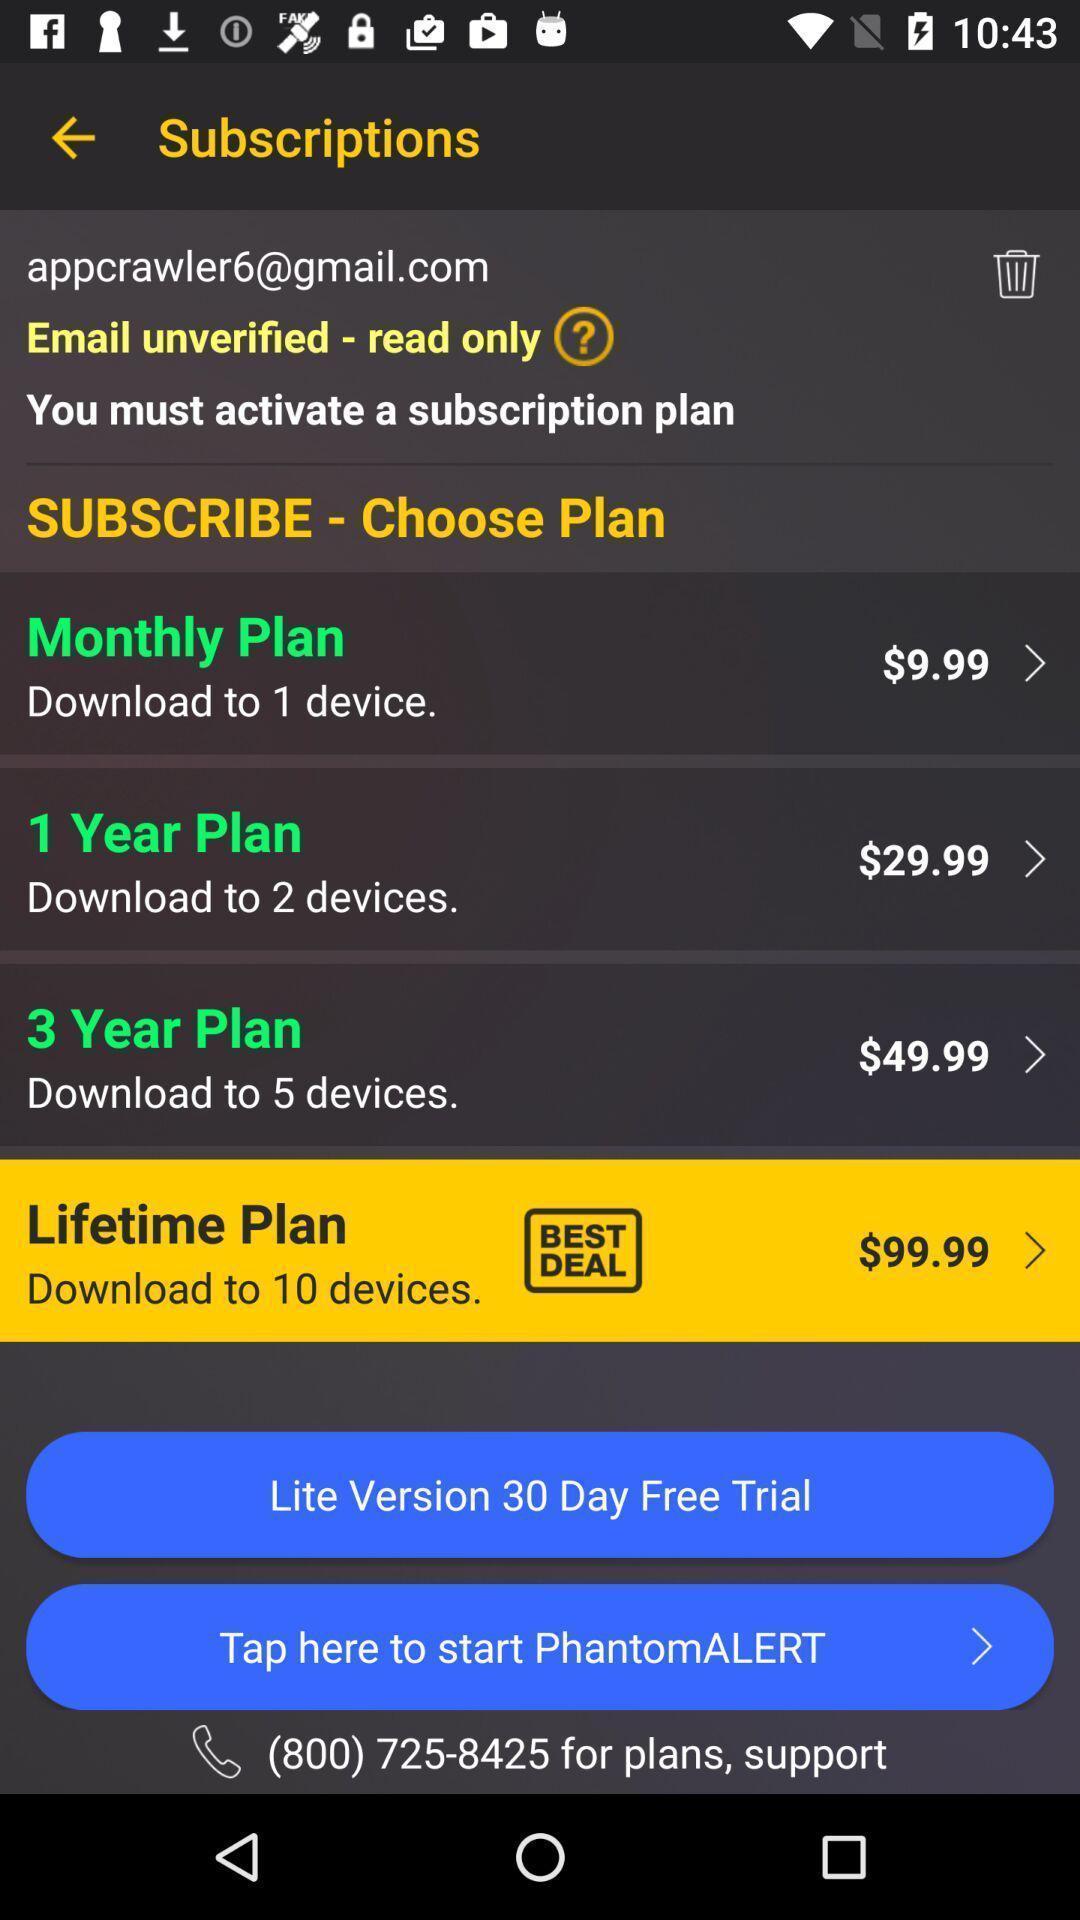Describe the content in this image. Subscriptions screen with some information in service app. 